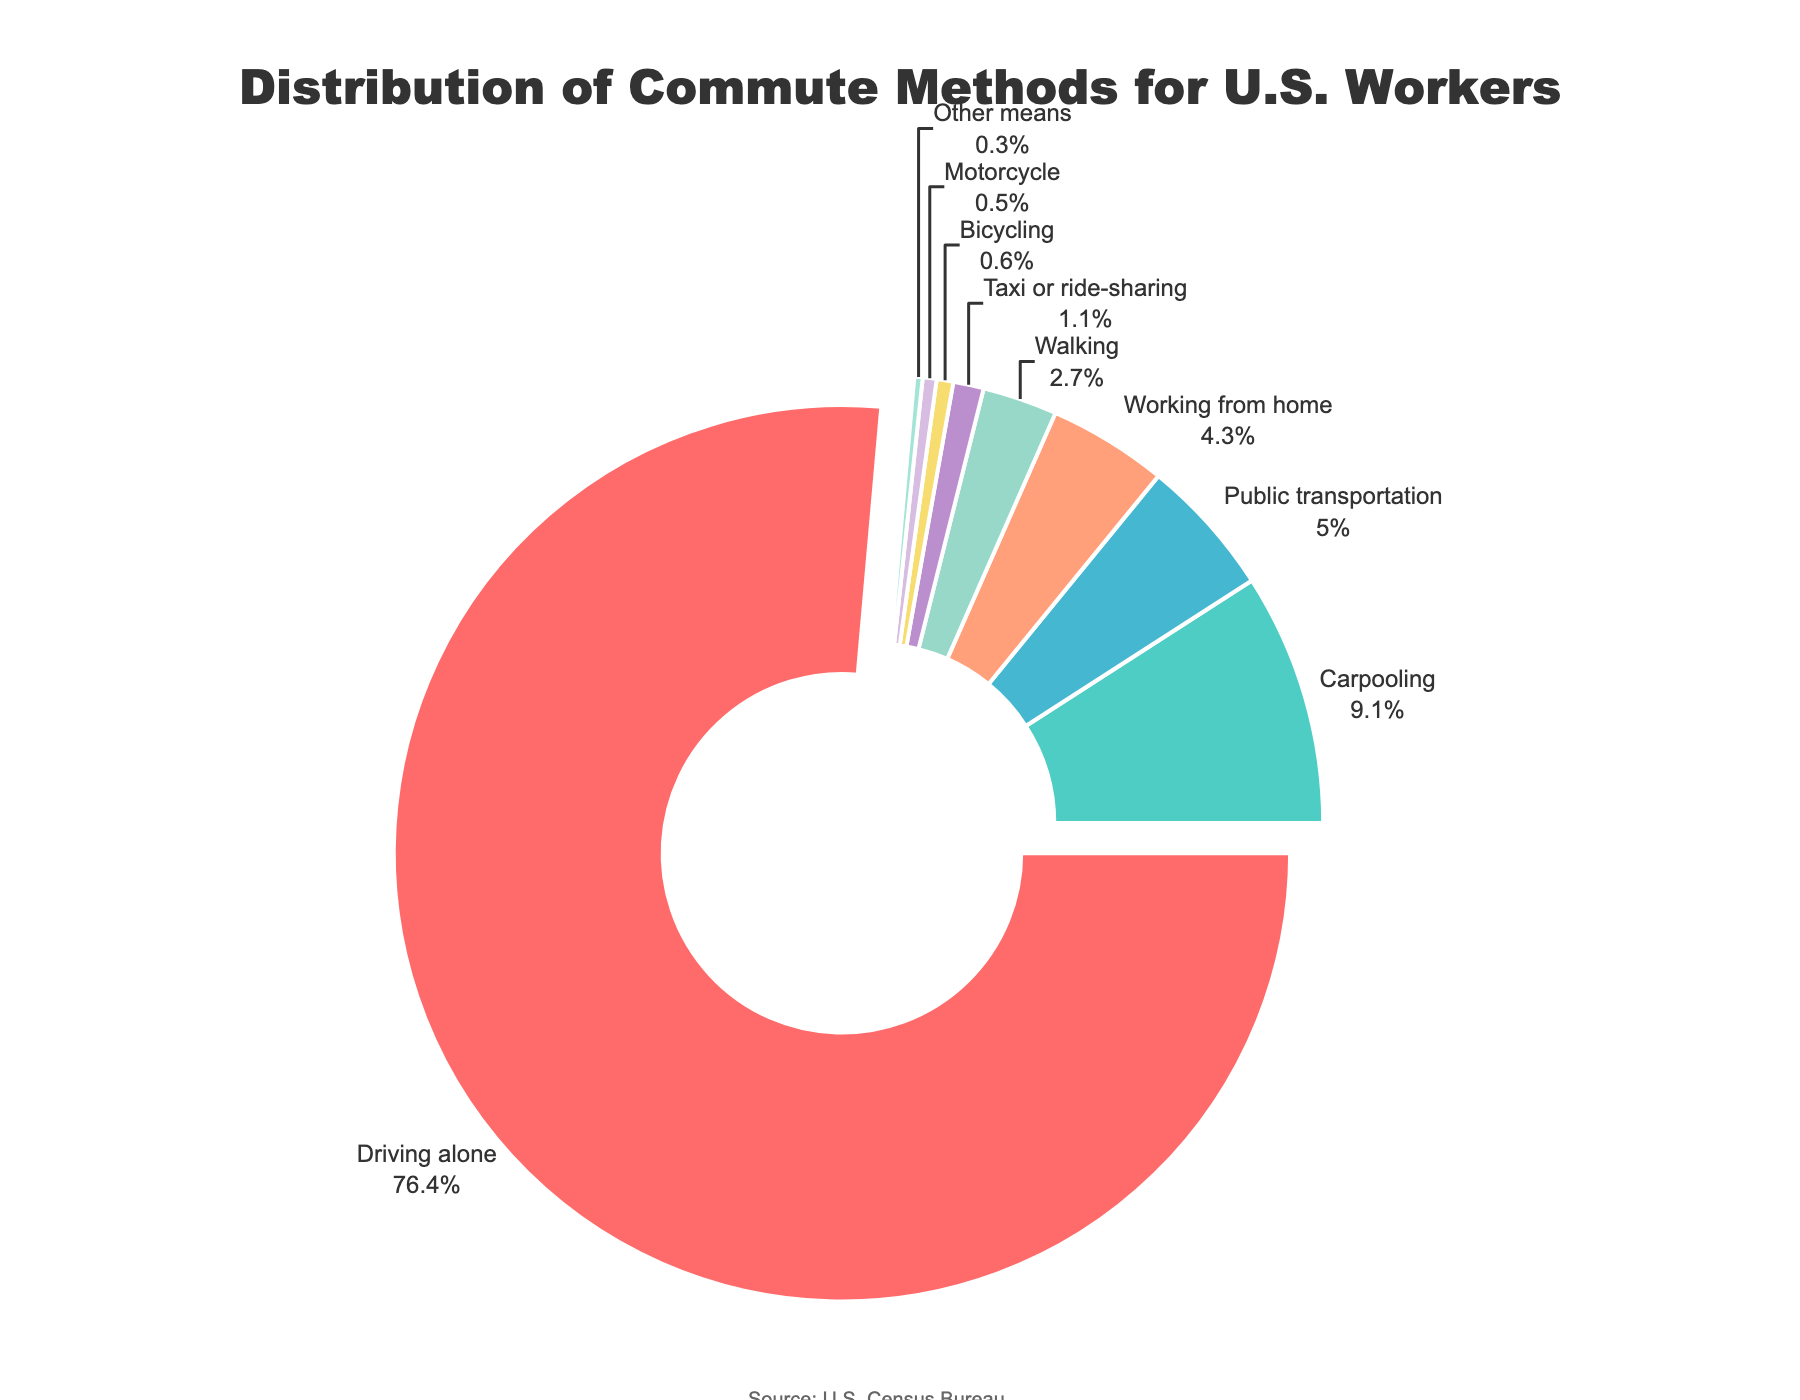What percentage of U.S. workers drive alone to work? The figure shows a pie chart with labels and percentages. Locate the slice labeled "Driving alone" to find the percentage.
Answer: 76.4% Which commute method has the lowest percentage of U.S. workers? Identify the slice in the pie chart with the smallest percentage. The "Other means" slice has the smallest segment.
Answer: Other means How much higher is the percentage of workers driving alone compared to those carpooling? Subtract the percentage of workers carpooling (9.1%) from the percentage of workers driving alone (76.4%).
Answer: 67.3% What is the combined percentage of U.S. workers using public transportation and working from home? Add the percentages for public transportation (5.0%) and working from home (4.3%).
Answer: 9.3% Which commute method is depicted in red on the pie chart? Identify the section of the pie chart shaded in red. The "Driving alone" section is colored red.
Answer: Driving alone Are there more U.S. workers walking or riding a bicycle to work? Compare the percentages of workers walking (2.7%) to those bicycling (0.6%).
Answer: Walking What is the total percentage of U.S. workers using some form of motorized vehicle (driving alone, carpooling, public transportation, taxi or ride-sharing, motorcycle)? Sum the percentages for driving alone (76.4%), carpooling (9.1%), public transportation (5.0%), taxi or ride-sharing (1.1%), and motorcycle (0.5%).
Answer: 92.1% Which method has a higher percentage: working from home or carpooling? Compare the percentages for working from home (4.3%) and carpooling (9.1%).
Answer: Carpooling What's the total percentage of U.S. workers using non-motorized commute methods (walking, bicycling)? Add the percentages for walking (2.7%) and bicycling (0.6%).
Answer: 3.3% What is the second most common commute method among U.S. workers? Find the method with the second largest percentage, which is carpooling at 9.1%.
Answer: Carpooling 